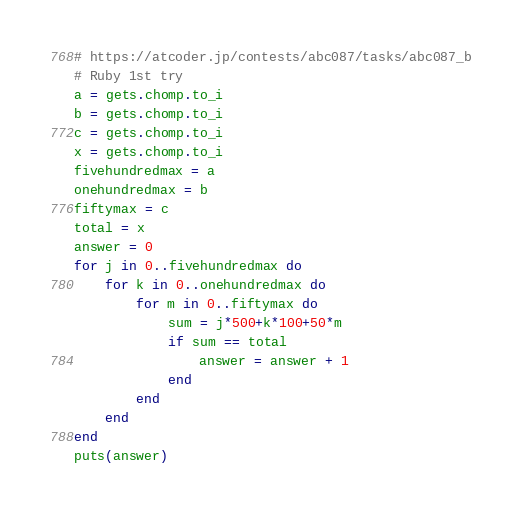<code> <loc_0><loc_0><loc_500><loc_500><_Ruby_># https://atcoder.jp/contests/abc087/tasks/abc087_b
# Ruby 1st try
a = gets.chomp.to_i
b = gets.chomp.to_i
c = gets.chomp.to_i
x = gets.chomp.to_i
fivehundredmax = a
onehundredmax = b
fiftymax = c
total = x
answer = 0
for j in 0..fivehundredmax do
    for k in 0..onehundredmax do
        for m in 0..fiftymax do
            sum = j*500+k*100+50*m
            if sum == total
                answer = answer + 1
            end
        end
    end
end
puts(answer)</code> 